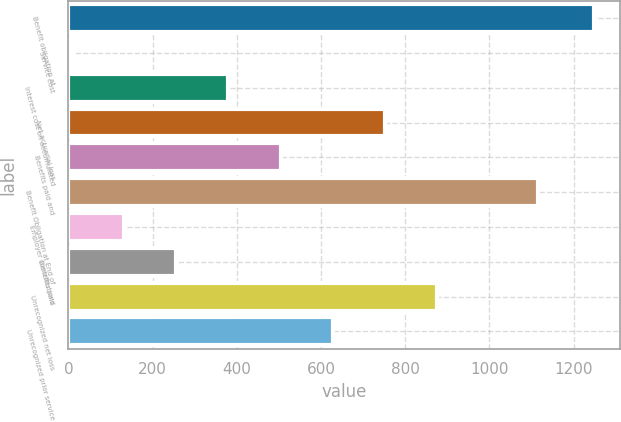<chart> <loc_0><loc_0><loc_500><loc_500><bar_chart><fcel>Benefit obligation at<fcel>Service cost<fcel>Interest cost on accumulated<fcel>Net actuarial loss<fcel>Benefits paid and<fcel>Benefit Obligation at End of<fcel>Employer contributions<fcel>Benefits paid<fcel>Unrecognized net loss<fcel>Unrecognized prior service<nl><fcel>1249<fcel>8<fcel>380.3<fcel>752.6<fcel>504.4<fcel>1115<fcel>132.1<fcel>256.2<fcel>876.7<fcel>628.5<nl></chart> 